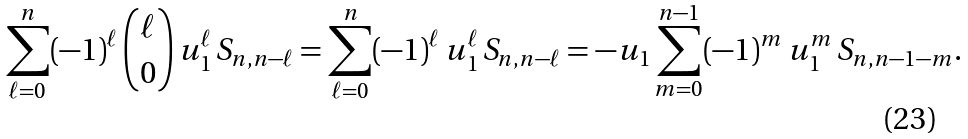Convert formula to latex. <formula><loc_0><loc_0><loc_500><loc_500>\sum _ { \ell = 0 } ^ { n } ( - 1 ) ^ { \ell } \, \binom { \ell } { 0 } \, u _ { 1 } ^ { \ell } \, S _ { n , n - \ell } = \sum _ { \ell = 0 } ^ { n } ( - 1 ) ^ { \ell } \, u _ { 1 } ^ { \ell } \, S _ { n , n - \ell } = - u _ { 1 } \sum _ { m = 0 } ^ { n - 1 } ( - 1 ) ^ { m } \, u _ { 1 } ^ { m } \, S _ { n , n - 1 - m } .</formula> 